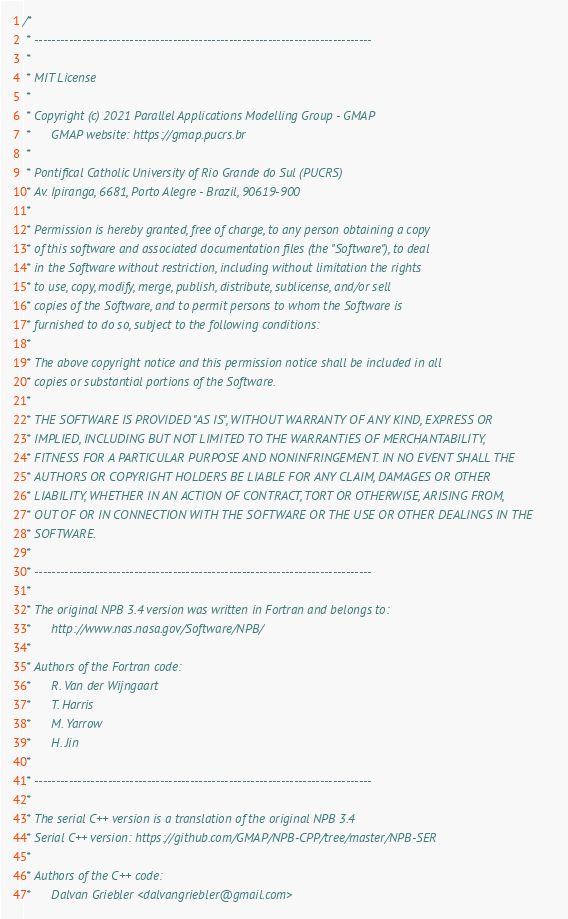<code> <loc_0><loc_0><loc_500><loc_500><_Cuda_>/* 
 * ------------------------------------------------------------------------------
 *
 * MIT License
 *
 * Copyright (c) 2021 Parallel Applications Modelling Group - GMAP
 *      GMAP website: https://gmap.pucrs.br
 *
 * Pontifical Catholic University of Rio Grande do Sul (PUCRS)
 * Av. Ipiranga, 6681, Porto Alegre - Brazil, 90619-900
 *
 * Permission is hereby granted, free of charge, to any person obtaining a copy
 * of this software and associated documentation files (the "Software"), to deal
 * in the Software without restriction, including without limitation the rights
 * to use, copy, modify, merge, publish, distribute, sublicense, and/or sell
 * copies of the Software, and to permit persons to whom the Software is
 * furnished to do so, subject to the following conditions:
 *
 * The above copyright notice and this permission notice shall be included in all
 * copies or substantial portions of the Software.
 *
 * THE SOFTWARE IS PROVIDED "AS IS", WITHOUT WARRANTY OF ANY KIND, EXPRESS OR
 * IMPLIED, INCLUDING BUT NOT LIMITED TO THE WARRANTIES OF MERCHANTABILITY,
 * FITNESS FOR A PARTICULAR PURPOSE AND NONINFRINGEMENT. IN NO EVENT SHALL THE
 * AUTHORS OR COPYRIGHT HOLDERS BE LIABLE FOR ANY CLAIM, DAMAGES OR OTHER
 * LIABILITY, WHETHER IN AN ACTION OF CONTRACT, TORT OR OTHERWISE, ARISING FROM,
 * OUT OF OR IN CONNECTION WITH THE SOFTWARE OR THE USE OR OTHER DEALINGS IN THE
 * SOFTWARE.
 *
 * ------------------------------------------------------------------------------
 *
 * The original NPB 3.4 version was written in Fortran and belongs to:
 *      http://www.nas.nasa.gov/Software/NPB/
 *
 * Authors of the Fortran code:
 *      R. Van der Wijngaart
 *      T. Harris
 *      M. Yarrow
 *      H. Jin
 *
 * ------------------------------------------------------------------------------
 *
 * The serial C++ version is a translation of the original NPB 3.4
 * Serial C++ version: https://github.com/GMAP/NPB-CPP/tree/master/NPB-SER
 *
 * Authors of the C++ code:
 *      Dalvan Griebler <dalvangriebler@gmail.com></code> 